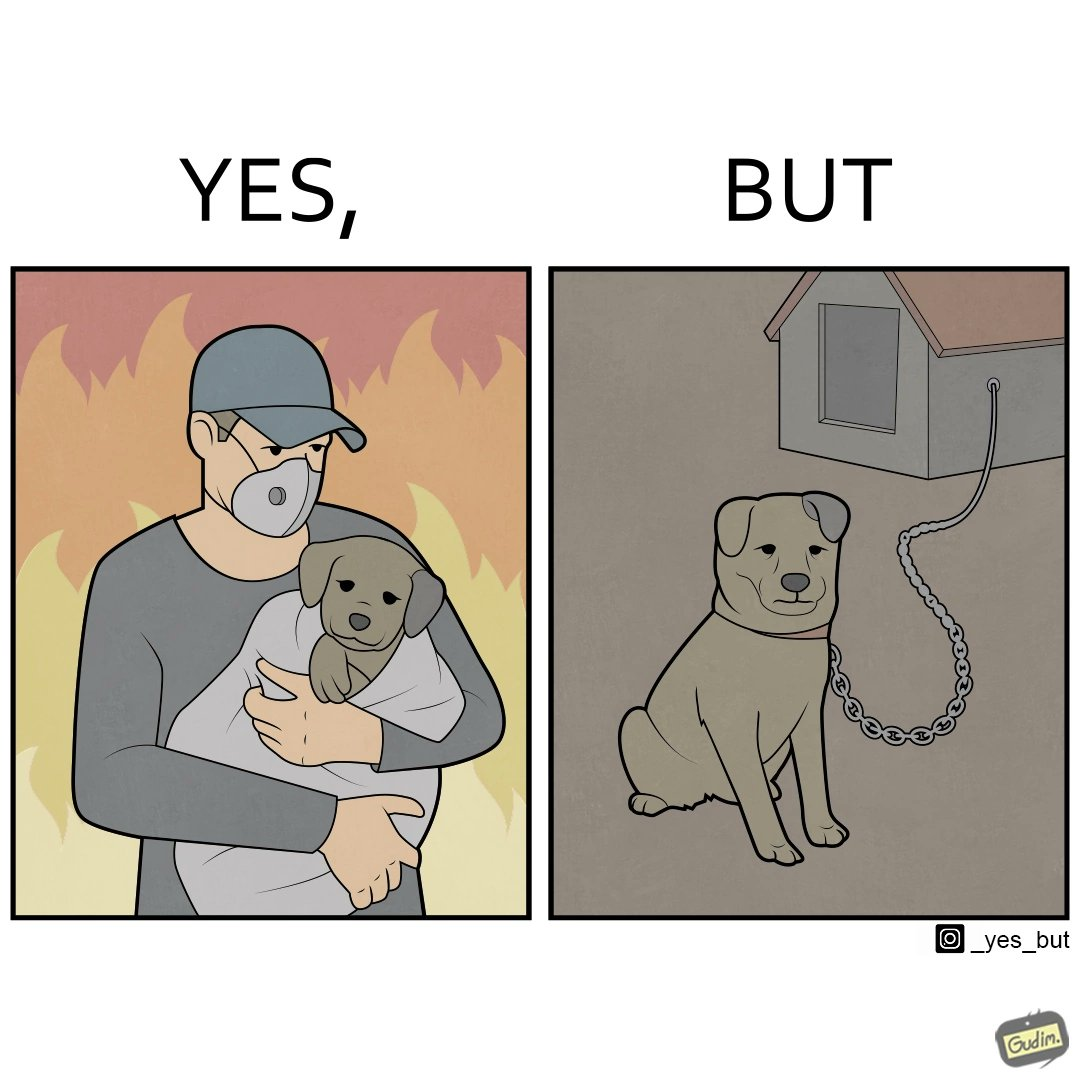What is shown in this image? The image is ironic, because in the left image the man is showing love and care for the puppy but in the right image the same puppy is shown to be chained in a kennel, which shows dual nature of human towards animals 